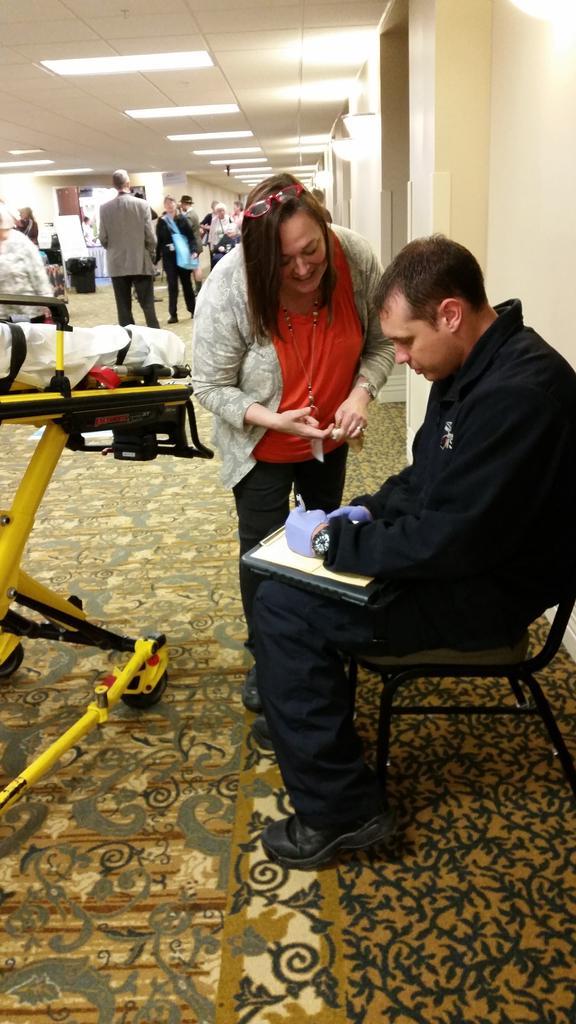In one or two sentences, can you explain what this image depicts? In this image there is a man sitting on the chair holding a pad in his hands. This woman wearing red t shirt is standing on the floor. In the background of the image we can see few people are there. 